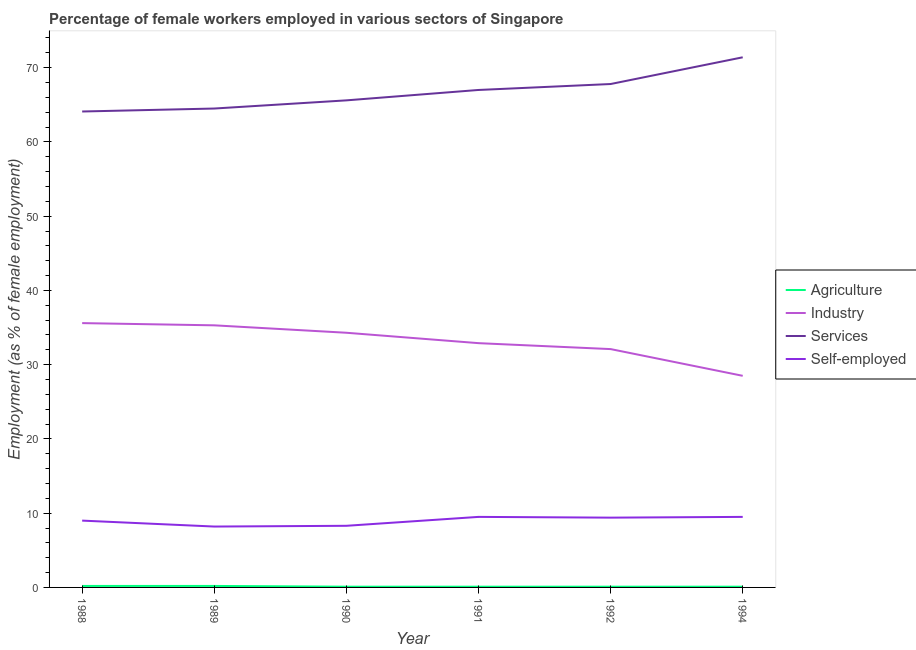How many different coloured lines are there?
Give a very brief answer. 4. Does the line corresponding to percentage of self employed female workers intersect with the line corresponding to percentage of female workers in services?
Give a very brief answer. No. What is the percentage of female workers in services in 1989?
Ensure brevity in your answer.  64.5. Across all years, what is the minimum percentage of female workers in agriculture?
Offer a terse response. 0.1. What is the total percentage of self employed female workers in the graph?
Ensure brevity in your answer.  53.9. What is the difference between the percentage of female workers in services in 1989 and that in 1992?
Keep it short and to the point. -3.3. What is the difference between the percentage of female workers in industry in 1992 and the percentage of self employed female workers in 1990?
Your answer should be compact. 23.8. What is the average percentage of female workers in industry per year?
Provide a short and direct response. 33.12. In the year 1990, what is the difference between the percentage of female workers in industry and percentage of female workers in agriculture?
Your answer should be very brief. 34.2. What is the ratio of the percentage of female workers in industry in 1991 to that in 1992?
Make the answer very short. 1.02. Is the percentage of female workers in agriculture in 1991 less than that in 1994?
Your response must be concise. No. What is the difference between the highest and the second highest percentage of female workers in industry?
Your answer should be very brief. 0.3. What is the difference between the highest and the lowest percentage of female workers in industry?
Ensure brevity in your answer.  7.1. In how many years, is the percentage of female workers in industry greater than the average percentage of female workers in industry taken over all years?
Your response must be concise. 3. Is the sum of the percentage of female workers in agriculture in 1990 and 1992 greater than the maximum percentage of self employed female workers across all years?
Offer a terse response. No. Is it the case that in every year, the sum of the percentage of female workers in industry and percentage of female workers in services is greater than the sum of percentage of female workers in agriculture and percentage of self employed female workers?
Make the answer very short. Yes. Does the percentage of female workers in agriculture monotonically increase over the years?
Ensure brevity in your answer.  No. Is the percentage of self employed female workers strictly greater than the percentage of female workers in services over the years?
Your answer should be very brief. No. Is the percentage of female workers in services strictly less than the percentage of female workers in agriculture over the years?
Provide a succinct answer. No. How many lines are there?
Give a very brief answer. 4. How many years are there in the graph?
Your answer should be compact. 6. What is the difference between two consecutive major ticks on the Y-axis?
Your answer should be compact. 10. Are the values on the major ticks of Y-axis written in scientific E-notation?
Make the answer very short. No. Does the graph contain grids?
Keep it short and to the point. No. How many legend labels are there?
Offer a terse response. 4. What is the title of the graph?
Keep it short and to the point. Percentage of female workers employed in various sectors of Singapore. What is the label or title of the Y-axis?
Offer a terse response. Employment (as % of female employment). What is the Employment (as % of female employment) in Agriculture in 1988?
Give a very brief answer. 0.2. What is the Employment (as % of female employment) of Industry in 1988?
Ensure brevity in your answer.  35.6. What is the Employment (as % of female employment) in Services in 1988?
Your response must be concise. 64.1. What is the Employment (as % of female employment) of Self-employed in 1988?
Your response must be concise. 9. What is the Employment (as % of female employment) of Agriculture in 1989?
Ensure brevity in your answer.  0.2. What is the Employment (as % of female employment) of Industry in 1989?
Your answer should be compact. 35.3. What is the Employment (as % of female employment) in Services in 1989?
Your answer should be compact. 64.5. What is the Employment (as % of female employment) of Self-employed in 1989?
Keep it short and to the point. 8.2. What is the Employment (as % of female employment) in Agriculture in 1990?
Ensure brevity in your answer.  0.1. What is the Employment (as % of female employment) of Industry in 1990?
Provide a short and direct response. 34.3. What is the Employment (as % of female employment) of Services in 1990?
Offer a terse response. 65.6. What is the Employment (as % of female employment) in Self-employed in 1990?
Your answer should be very brief. 8.3. What is the Employment (as % of female employment) in Agriculture in 1991?
Your response must be concise. 0.1. What is the Employment (as % of female employment) in Industry in 1991?
Ensure brevity in your answer.  32.9. What is the Employment (as % of female employment) of Services in 1991?
Provide a short and direct response. 67. What is the Employment (as % of female employment) of Agriculture in 1992?
Ensure brevity in your answer.  0.1. What is the Employment (as % of female employment) in Industry in 1992?
Your answer should be very brief. 32.1. What is the Employment (as % of female employment) in Services in 1992?
Provide a succinct answer. 67.8. What is the Employment (as % of female employment) in Self-employed in 1992?
Give a very brief answer. 9.4. What is the Employment (as % of female employment) in Agriculture in 1994?
Make the answer very short. 0.1. What is the Employment (as % of female employment) of Industry in 1994?
Ensure brevity in your answer.  28.5. What is the Employment (as % of female employment) in Services in 1994?
Provide a short and direct response. 71.4. What is the Employment (as % of female employment) in Self-employed in 1994?
Offer a terse response. 9.5. Across all years, what is the maximum Employment (as % of female employment) of Agriculture?
Provide a short and direct response. 0.2. Across all years, what is the maximum Employment (as % of female employment) in Industry?
Offer a very short reply. 35.6. Across all years, what is the maximum Employment (as % of female employment) of Services?
Offer a very short reply. 71.4. Across all years, what is the minimum Employment (as % of female employment) of Agriculture?
Keep it short and to the point. 0.1. Across all years, what is the minimum Employment (as % of female employment) of Industry?
Offer a terse response. 28.5. Across all years, what is the minimum Employment (as % of female employment) in Services?
Provide a short and direct response. 64.1. Across all years, what is the minimum Employment (as % of female employment) of Self-employed?
Your response must be concise. 8.2. What is the total Employment (as % of female employment) of Industry in the graph?
Provide a succinct answer. 198.7. What is the total Employment (as % of female employment) in Services in the graph?
Provide a short and direct response. 400.4. What is the total Employment (as % of female employment) of Self-employed in the graph?
Provide a succinct answer. 53.9. What is the difference between the Employment (as % of female employment) in Agriculture in 1988 and that in 1989?
Offer a terse response. 0. What is the difference between the Employment (as % of female employment) in Industry in 1988 and that in 1989?
Make the answer very short. 0.3. What is the difference between the Employment (as % of female employment) in Self-employed in 1988 and that in 1989?
Offer a terse response. 0.8. What is the difference between the Employment (as % of female employment) of Agriculture in 1988 and that in 1990?
Ensure brevity in your answer.  0.1. What is the difference between the Employment (as % of female employment) of Industry in 1988 and that in 1991?
Your answer should be very brief. 2.7. What is the difference between the Employment (as % of female employment) of Services in 1988 and that in 1991?
Give a very brief answer. -2.9. What is the difference between the Employment (as % of female employment) in Agriculture in 1988 and that in 1992?
Keep it short and to the point. 0.1. What is the difference between the Employment (as % of female employment) in Services in 1988 and that in 1992?
Provide a succinct answer. -3.7. What is the difference between the Employment (as % of female employment) in Self-employed in 1988 and that in 1992?
Your answer should be very brief. -0.4. What is the difference between the Employment (as % of female employment) of Agriculture in 1988 and that in 1994?
Your answer should be compact. 0.1. What is the difference between the Employment (as % of female employment) in Services in 1988 and that in 1994?
Your answer should be very brief. -7.3. What is the difference between the Employment (as % of female employment) in Agriculture in 1989 and that in 1990?
Give a very brief answer. 0.1. What is the difference between the Employment (as % of female employment) in Self-employed in 1989 and that in 1990?
Make the answer very short. -0.1. What is the difference between the Employment (as % of female employment) in Agriculture in 1989 and that in 1991?
Ensure brevity in your answer.  0.1. What is the difference between the Employment (as % of female employment) in Services in 1989 and that in 1991?
Offer a terse response. -2.5. What is the difference between the Employment (as % of female employment) of Agriculture in 1989 and that in 1992?
Your answer should be compact. 0.1. What is the difference between the Employment (as % of female employment) of Self-employed in 1989 and that in 1992?
Your answer should be compact. -1.2. What is the difference between the Employment (as % of female employment) of Agriculture in 1989 and that in 1994?
Ensure brevity in your answer.  0.1. What is the difference between the Employment (as % of female employment) in Industry in 1989 and that in 1994?
Provide a succinct answer. 6.8. What is the difference between the Employment (as % of female employment) in Agriculture in 1990 and that in 1991?
Provide a succinct answer. 0. What is the difference between the Employment (as % of female employment) in Agriculture in 1990 and that in 1992?
Provide a short and direct response. 0. What is the difference between the Employment (as % of female employment) of Services in 1990 and that in 1994?
Give a very brief answer. -5.8. What is the difference between the Employment (as % of female employment) in Self-employed in 1991 and that in 1992?
Make the answer very short. 0.1. What is the difference between the Employment (as % of female employment) in Services in 1991 and that in 1994?
Your response must be concise. -4.4. What is the difference between the Employment (as % of female employment) in Self-employed in 1991 and that in 1994?
Your answer should be very brief. 0. What is the difference between the Employment (as % of female employment) in Industry in 1992 and that in 1994?
Provide a succinct answer. 3.6. What is the difference between the Employment (as % of female employment) in Self-employed in 1992 and that in 1994?
Your response must be concise. -0.1. What is the difference between the Employment (as % of female employment) in Agriculture in 1988 and the Employment (as % of female employment) in Industry in 1989?
Keep it short and to the point. -35.1. What is the difference between the Employment (as % of female employment) in Agriculture in 1988 and the Employment (as % of female employment) in Services in 1989?
Provide a short and direct response. -64.3. What is the difference between the Employment (as % of female employment) in Industry in 1988 and the Employment (as % of female employment) in Services in 1989?
Keep it short and to the point. -28.9. What is the difference between the Employment (as % of female employment) of Industry in 1988 and the Employment (as % of female employment) of Self-employed in 1989?
Your answer should be very brief. 27.4. What is the difference between the Employment (as % of female employment) of Services in 1988 and the Employment (as % of female employment) of Self-employed in 1989?
Keep it short and to the point. 55.9. What is the difference between the Employment (as % of female employment) of Agriculture in 1988 and the Employment (as % of female employment) of Industry in 1990?
Ensure brevity in your answer.  -34.1. What is the difference between the Employment (as % of female employment) in Agriculture in 1988 and the Employment (as % of female employment) in Services in 1990?
Your response must be concise. -65.4. What is the difference between the Employment (as % of female employment) in Industry in 1988 and the Employment (as % of female employment) in Services in 1990?
Make the answer very short. -30. What is the difference between the Employment (as % of female employment) of Industry in 1988 and the Employment (as % of female employment) of Self-employed in 1990?
Provide a succinct answer. 27.3. What is the difference between the Employment (as % of female employment) of Services in 1988 and the Employment (as % of female employment) of Self-employed in 1990?
Make the answer very short. 55.8. What is the difference between the Employment (as % of female employment) of Agriculture in 1988 and the Employment (as % of female employment) of Industry in 1991?
Provide a short and direct response. -32.7. What is the difference between the Employment (as % of female employment) in Agriculture in 1988 and the Employment (as % of female employment) in Services in 1991?
Your answer should be very brief. -66.8. What is the difference between the Employment (as % of female employment) of Industry in 1988 and the Employment (as % of female employment) of Services in 1991?
Make the answer very short. -31.4. What is the difference between the Employment (as % of female employment) in Industry in 1988 and the Employment (as % of female employment) in Self-employed in 1991?
Your response must be concise. 26.1. What is the difference between the Employment (as % of female employment) in Services in 1988 and the Employment (as % of female employment) in Self-employed in 1991?
Your answer should be very brief. 54.6. What is the difference between the Employment (as % of female employment) in Agriculture in 1988 and the Employment (as % of female employment) in Industry in 1992?
Your answer should be very brief. -31.9. What is the difference between the Employment (as % of female employment) in Agriculture in 1988 and the Employment (as % of female employment) in Services in 1992?
Ensure brevity in your answer.  -67.6. What is the difference between the Employment (as % of female employment) of Industry in 1988 and the Employment (as % of female employment) of Services in 1992?
Make the answer very short. -32.2. What is the difference between the Employment (as % of female employment) of Industry in 1988 and the Employment (as % of female employment) of Self-employed in 1992?
Your answer should be very brief. 26.2. What is the difference between the Employment (as % of female employment) of Services in 1988 and the Employment (as % of female employment) of Self-employed in 1992?
Keep it short and to the point. 54.7. What is the difference between the Employment (as % of female employment) of Agriculture in 1988 and the Employment (as % of female employment) of Industry in 1994?
Make the answer very short. -28.3. What is the difference between the Employment (as % of female employment) in Agriculture in 1988 and the Employment (as % of female employment) in Services in 1994?
Your answer should be very brief. -71.2. What is the difference between the Employment (as % of female employment) in Industry in 1988 and the Employment (as % of female employment) in Services in 1994?
Your response must be concise. -35.8. What is the difference between the Employment (as % of female employment) in Industry in 1988 and the Employment (as % of female employment) in Self-employed in 1994?
Give a very brief answer. 26.1. What is the difference between the Employment (as % of female employment) of Services in 1988 and the Employment (as % of female employment) of Self-employed in 1994?
Make the answer very short. 54.6. What is the difference between the Employment (as % of female employment) in Agriculture in 1989 and the Employment (as % of female employment) in Industry in 1990?
Keep it short and to the point. -34.1. What is the difference between the Employment (as % of female employment) in Agriculture in 1989 and the Employment (as % of female employment) in Services in 1990?
Give a very brief answer. -65.4. What is the difference between the Employment (as % of female employment) of Industry in 1989 and the Employment (as % of female employment) of Services in 1990?
Keep it short and to the point. -30.3. What is the difference between the Employment (as % of female employment) in Industry in 1989 and the Employment (as % of female employment) in Self-employed in 1990?
Your answer should be compact. 27. What is the difference between the Employment (as % of female employment) of Services in 1989 and the Employment (as % of female employment) of Self-employed in 1990?
Offer a very short reply. 56.2. What is the difference between the Employment (as % of female employment) in Agriculture in 1989 and the Employment (as % of female employment) in Industry in 1991?
Your answer should be very brief. -32.7. What is the difference between the Employment (as % of female employment) in Agriculture in 1989 and the Employment (as % of female employment) in Services in 1991?
Offer a very short reply. -66.8. What is the difference between the Employment (as % of female employment) in Industry in 1989 and the Employment (as % of female employment) in Services in 1991?
Keep it short and to the point. -31.7. What is the difference between the Employment (as % of female employment) of Industry in 1989 and the Employment (as % of female employment) of Self-employed in 1991?
Offer a terse response. 25.8. What is the difference between the Employment (as % of female employment) in Services in 1989 and the Employment (as % of female employment) in Self-employed in 1991?
Provide a short and direct response. 55. What is the difference between the Employment (as % of female employment) of Agriculture in 1989 and the Employment (as % of female employment) of Industry in 1992?
Your answer should be compact. -31.9. What is the difference between the Employment (as % of female employment) in Agriculture in 1989 and the Employment (as % of female employment) in Services in 1992?
Give a very brief answer. -67.6. What is the difference between the Employment (as % of female employment) of Industry in 1989 and the Employment (as % of female employment) of Services in 1992?
Offer a terse response. -32.5. What is the difference between the Employment (as % of female employment) in Industry in 1989 and the Employment (as % of female employment) in Self-employed in 1992?
Ensure brevity in your answer.  25.9. What is the difference between the Employment (as % of female employment) in Services in 1989 and the Employment (as % of female employment) in Self-employed in 1992?
Your answer should be very brief. 55.1. What is the difference between the Employment (as % of female employment) of Agriculture in 1989 and the Employment (as % of female employment) of Industry in 1994?
Your answer should be very brief. -28.3. What is the difference between the Employment (as % of female employment) of Agriculture in 1989 and the Employment (as % of female employment) of Services in 1994?
Offer a very short reply. -71.2. What is the difference between the Employment (as % of female employment) of Industry in 1989 and the Employment (as % of female employment) of Services in 1994?
Provide a short and direct response. -36.1. What is the difference between the Employment (as % of female employment) in Industry in 1989 and the Employment (as % of female employment) in Self-employed in 1994?
Make the answer very short. 25.8. What is the difference between the Employment (as % of female employment) in Services in 1989 and the Employment (as % of female employment) in Self-employed in 1994?
Your response must be concise. 55. What is the difference between the Employment (as % of female employment) in Agriculture in 1990 and the Employment (as % of female employment) in Industry in 1991?
Provide a succinct answer. -32.8. What is the difference between the Employment (as % of female employment) in Agriculture in 1990 and the Employment (as % of female employment) in Services in 1991?
Make the answer very short. -66.9. What is the difference between the Employment (as % of female employment) in Industry in 1990 and the Employment (as % of female employment) in Services in 1991?
Ensure brevity in your answer.  -32.7. What is the difference between the Employment (as % of female employment) of Industry in 1990 and the Employment (as % of female employment) of Self-employed in 1991?
Ensure brevity in your answer.  24.8. What is the difference between the Employment (as % of female employment) of Services in 1990 and the Employment (as % of female employment) of Self-employed in 1991?
Provide a short and direct response. 56.1. What is the difference between the Employment (as % of female employment) in Agriculture in 1990 and the Employment (as % of female employment) in Industry in 1992?
Give a very brief answer. -32. What is the difference between the Employment (as % of female employment) of Agriculture in 1990 and the Employment (as % of female employment) of Services in 1992?
Provide a succinct answer. -67.7. What is the difference between the Employment (as % of female employment) in Industry in 1990 and the Employment (as % of female employment) in Services in 1992?
Keep it short and to the point. -33.5. What is the difference between the Employment (as % of female employment) in Industry in 1990 and the Employment (as % of female employment) in Self-employed in 1992?
Make the answer very short. 24.9. What is the difference between the Employment (as % of female employment) in Services in 1990 and the Employment (as % of female employment) in Self-employed in 1992?
Offer a terse response. 56.2. What is the difference between the Employment (as % of female employment) in Agriculture in 1990 and the Employment (as % of female employment) in Industry in 1994?
Your answer should be very brief. -28.4. What is the difference between the Employment (as % of female employment) of Agriculture in 1990 and the Employment (as % of female employment) of Services in 1994?
Your answer should be compact. -71.3. What is the difference between the Employment (as % of female employment) in Agriculture in 1990 and the Employment (as % of female employment) in Self-employed in 1994?
Provide a short and direct response. -9.4. What is the difference between the Employment (as % of female employment) in Industry in 1990 and the Employment (as % of female employment) in Services in 1994?
Provide a short and direct response. -37.1. What is the difference between the Employment (as % of female employment) of Industry in 1990 and the Employment (as % of female employment) of Self-employed in 1994?
Your answer should be compact. 24.8. What is the difference between the Employment (as % of female employment) of Services in 1990 and the Employment (as % of female employment) of Self-employed in 1994?
Provide a succinct answer. 56.1. What is the difference between the Employment (as % of female employment) of Agriculture in 1991 and the Employment (as % of female employment) of Industry in 1992?
Provide a short and direct response. -32. What is the difference between the Employment (as % of female employment) of Agriculture in 1991 and the Employment (as % of female employment) of Services in 1992?
Your answer should be very brief. -67.7. What is the difference between the Employment (as % of female employment) in Agriculture in 1991 and the Employment (as % of female employment) in Self-employed in 1992?
Provide a succinct answer. -9.3. What is the difference between the Employment (as % of female employment) in Industry in 1991 and the Employment (as % of female employment) in Services in 1992?
Your answer should be compact. -34.9. What is the difference between the Employment (as % of female employment) of Services in 1991 and the Employment (as % of female employment) of Self-employed in 1992?
Offer a terse response. 57.6. What is the difference between the Employment (as % of female employment) in Agriculture in 1991 and the Employment (as % of female employment) in Industry in 1994?
Offer a terse response. -28.4. What is the difference between the Employment (as % of female employment) in Agriculture in 1991 and the Employment (as % of female employment) in Services in 1994?
Your answer should be very brief. -71.3. What is the difference between the Employment (as % of female employment) of Industry in 1991 and the Employment (as % of female employment) of Services in 1994?
Provide a short and direct response. -38.5. What is the difference between the Employment (as % of female employment) in Industry in 1991 and the Employment (as % of female employment) in Self-employed in 1994?
Keep it short and to the point. 23.4. What is the difference between the Employment (as % of female employment) of Services in 1991 and the Employment (as % of female employment) of Self-employed in 1994?
Keep it short and to the point. 57.5. What is the difference between the Employment (as % of female employment) of Agriculture in 1992 and the Employment (as % of female employment) of Industry in 1994?
Your answer should be very brief. -28.4. What is the difference between the Employment (as % of female employment) of Agriculture in 1992 and the Employment (as % of female employment) of Services in 1994?
Make the answer very short. -71.3. What is the difference between the Employment (as % of female employment) in Agriculture in 1992 and the Employment (as % of female employment) in Self-employed in 1994?
Make the answer very short. -9.4. What is the difference between the Employment (as % of female employment) of Industry in 1992 and the Employment (as % of female employment) of Services in 1994?
Your answer should be compact. -39.3. What is the difference between the Employment (as % of female employment) in Industry in 1992 and the Employment (as % of female employment) in Self-employed in 1994?
Keep it short and to the point. 22.6. What is the difference between the Employment (as % of female employment) in Services in 1992 and the Employment (as % of female employment) in Self-employed in 1994?
Your answer should be very brief. 58.3. What is the average Employment (as % of female employment) of Agriculture per year?
Offer a very short reply. 0.13. What is the average Employment (as % of female employment) of Industry per year?
Offer a terse response. 33.12. What is the average Employment (as % of female employment) in Services per year?
Your answer should be very brief. 66.73. What is the average Employment (as % of female employment) of Self-employed per year?
Make the answer very short. 8.98. In the year 1988, what is the difference between the Employment (as % of female employment) in Agriculture and Employment (as % of female employment) in Industry?
Offer a very short reply. -35.4. In the year 1988, what is the difference between the Employment (as % of female employment) of Agriculture and Employment (as % of female employment) of Services?
Give a very brief answer. -63.9. In the year 1988, what is the difference between the Employment (as % of female employment) of Agriculture and Employment (as % of female employment) of Self-employed?
Provide a succinct answer. -8.8. In the year 1988, what is the difference between the Employment (as % of female employment) of Industry and Employment (as % of female employment) of Services?
Keep it short and to the point. -28.5. In the year 1988, what is the difference between the Employment (as % of female employment) of Industry and Employment (as % of female employment) of Self-employed?
Your response must be concise. 26.6. In the year 1988, what is the difference between the Employment (as % of female employment) of Services and Employment (as % of female employment) of Self-employed?
Provide a succinct answer. 55.1. In the year 1989, what is the difference between the Employment (as % of female employment) of Agriculture and Employment (as % of female employment) of Industry?
Your answer should be compact. -35.1. In the year 1989, what is the difference between the Employment (as % of female employment) in Agriculture and Employment (as % of female employment) in Services?
Give a very brief answer. -64.3. In the year 1989, what is the difference between the Employment (as % of female employment) of Industry and Employment (as % of female employment) of Services?
Your answer should be very brief. -29.2. In the year 1989, what is the difference between the Employment (as % of female employment) of Industry and Employment (as % of female employment) of Self-employed?
Give a very brief answer. 27.1. In the year 1989, what is the difference between the Employment (as % of female employment) in Services and Employment (as % of female employment) in Self-employed?
Keep it short and to the point. 56.3. In the year 1990, what is the difference between the Employment (as % of female employment) of Agriculture and Employment (as % of female employment) of Industry?
Provide a short and direct response. -34.2. In the year 1990, what is the difference between the Employment (as % of female employment) in Agriculture and Employment (as % of female employment) in Services?
Offer a very short reply. -65.5. In the year 1990, what is the difference between the Employment (as % of female employment) of Agriculture and Employment (as % of female employment) of Self-employed?
Give a very brief answer. -8.2. In the year 1990, what is the difference between the Employment (as % of female employment) of Industry and Employment (as % of female employment) of Services?
Make the answer very short. -31.3. In the year 1990, what is the difference between the Employment (as % of female employment) in Services and Employment (as % of female employment) in Self-employed?
Ensure brevity in your answer.  57.3. In the year 1991, what is the difference between the Employment (as % of female employment) in Agriculture and Employment (as % of female employment) in Industry?
Provide a short and direct response. -32.8. In the year 1991, what is the difference between the Employment (as % of female employment) in Agriculture and Employment (as % of female employment) in Services?
Offer a very short reply. -66.9. In the year 1991, what is the difference between the Employment (as % of female employment) in Agriculture and Employment (as % of female employment) in Self-employed?
Make the answer very short. -9.4. In the year 1991, what is the difference between the Employment (as % of female employment) of Industry and Employment (as % of female employment) of Services?
Your answer should be very brief. -34.1. In the year 1991, what is the difference between the Employment (as % of female employment) of Industry and Employment (as % of female employment) of Self-employed?
Your answer should be compact. 23.4. In the year 1991, what is the difference between the Employment (as % of female employment) of Services and Employment (as % of female employment) of Self-employed?
Provide a short and direct response. 57.5. In the year 1992, what is the difference between the Employment (as % of female employment) of Agriculture and Employment (as % of female employment) of Industry?
Your answer should be very brief. -32. In the year 1992, what is the difference between the Employment (as % of female employment) in Agriculture and Employment (as % of female employment) in Services?
Provide a short and direct response. -67.7. In the year 1992, what is the difference between the Employment (as % of female employment) of Agriculture and Employment (as % of female employment) of Self-employed?
Your response must be concise. -9.3. In the year 1992, what is the difference between the Employment (as % of female employment) in Industry and Employment (as % of female employment) in Services?
Give a very brief answer. -35.7. In the year 1992, what is the difference between the Employment (as % of female employment) of Industry and Employment (as % of female employment) of Self-employed?
Provide a succinct answer. 22.7. In the year 1992, what is the difference between the Employment (as % of female employment) in Services and Employment (as % of female employment) in Self-employed?
Provide a short and direct response. 58.4. In the year 1994, what is the difference between the Employment (as % of female employment) of Agriculture and Employment (as % of female employment) of Industry?
Your answer should be compact. -28.4. In the year 1994, what is the difference between the Employment (as % of female employment) in Agriculture and Employment (as % of female employment) in Services?
Give a very brief answer. -71.3. In the year 1994, what is the difference between the Employment (as % of female employment) of Agriculture and Employment (as % of female employment) of Self-employed?
Keep it short and to the point. -9.4. In the year 1994, what is the difference between the Employment (as % of female employment) of Industry and Employment (as % of female employment) of Services?
Make the answer very short. -42.9. In the year 1994, what is the difference between the Employment (as % of female employment) in Services and Employment (as % of female employment) in Self-employed?
Your answer should be compact. 61.9. What is the ratio of the Employment (as % of female employment) of Agriculture in 1988 to that in 1989?
Your response must be concise. 1. What is the ratio of the Employment (as % of female employment) of Industry in 1988 to that in 1989?
Your response must be concise. 1.01. What is the ratio of the Employment (as % of female employment) of Services in 1988 to that in 1989?
Provide a short and direct response. 0.99. What is the ratio of the Employment (as % of female employment) of Self-employed in 1988 to that in 1989?
Make the answer very short. 1.1. What is the ratio of the Employment (as % of female employment) of Agriculture in 1988 to that in 1990?
Give a very brief answer. 2. What is the ratio of the Employment (as % of female employment) of Industry in 1988 to that in 1990?
Provide a succinct answer. 1.04. What is the ratio of the Employment (as % of female employment) of Services in 1988 to that in 1990?
Make the answer very short. 0.98. What is the ratio of the Employment (as % of female employment) in Self-employed in 1988 to that in 1990?
Your response must be concise. 1.08. What is the ratio of the Employment (as % of female employment) of Industry in 1988 to that in 1991?
Provide a short and direct response. 1.08. What is the ratio of the Employment (as % of female employment) in Services in 1988 to that in 1991?
Your response must be concise. 0.96. What is the ratio of the Employment (as % of female employment) of Industry in 1988 to that in 1992?
Offer a very short reply. 1.11. What is the ratio of the Employment (as % of female employment) in Services in 1988 to that in 1992?
Provide a succinct answer. 0.95. What is the ratio of the Employment (as % of female employment) of Self-employed in 1988 to that in 1992?
Your answer should be compact. 0.96. What is the ratio of the Employment (as % of female employment) of Industry in 1988 to that in 1994?
Give a very brief answer. 1.25. What is the ratio of the Employment (as % of female employment) of Services in 1988 to that in 1994?
Provide a short and direct response. 0.9. What is the ratio of the Employment (as % of female employment) in Self-employed in 1988 to that in 1994?
Offer a very short reply. 0.95. What is the ratio of the Employment (as % of female employment) in Industry in 1989 to that in 1990?
Provide a short and direct response. 1.03. What is the ratio of the Employment (as % of female employment) in Services in 1989 to that in 1990?
Your response must be concise. 0.98. What is the ratio of the Employment (as % of female employment) in Agriculture in 1989 to that in 1991?
Make the answer very short. 2. What is the ratio of the Employment (as % of female employment) of Industry in 1989 to that in 1991?
Ensure brevity in your answer.  1.07. What is the ratio of the Employment (as % of female employment) in Services in 1989 to that in 1991?
Ensure brevity in your answer.  0.96. What is the ratio of the Employment (as % of female employment) of Self-employed in 1989 to that in 1991?
Offer a terse response. 0.86. What is the ratio of the Employment (as % of female employment) of Industry in 1989 to that in 1992?
Your answer should be very brief. 1.1. What is the ratio of the Employment (as % of female employment) in Services in 1989 to that in 1992?
Offer a terse response. 0.95. What is the ratio of the Employment (as % of female employment) of Self-employed in 1989 to that in 1992?
Ensure brevity in your answer.  0.87. What is the ratio of the Employment (as % of female employment) in Agriculture in 1989 to that in 1994?
Provide a succinct answer. 2. What is the ratio of the Employment (as % of female employment) in Industry in 1989 to that in 1994?
Keep it short and to the point. 1.24. What is the ratio of the Employment (as % of female employment) of Services in 1989 to that in 1994?
Ensure brevity in your answer.  0.9. What is the ratio of the Employment (as % of female employment) in Self-employed in 1989 to that in 1994?
Your answer should be very brief. 0.86. What is the ratio of the Employment (as % of female employment) of Agriculture in 1990 to that in 1991?
Your answer should be compact. 1. What is the ratio of the Employment (as % of female employment) of Industry in 1990 to that in 1991?
Keep it short and to the point. 1.04. What is the ratio of the Employment (as % of female employment) of Services in 1990 to that in 1991?
Make the answer very short. 0.98. What is the ratio of the Employment (as % of female employment) of Self-employed in 1990 to that in 1991?
Your response must be concise. 0.87. What is the ratio of the Employment (as % of female employment) in Industry in 1990 to that in 1992?
Make the answer very short. 1.07. What is the ratio of the Employment (as % of female employment) of Services in 1990 to that in 1992?
Ensure brevity in your answer.  0.97. What is the ratio of the Employment (as % of female employment) in Self-employed in 1990 to that in 1992?
Provide a succinct answer. 0.88. What is the ratio of the Employment (as % of female employment) of Agriculture in 1990 to that in 1994?
Your answer should be very brief. 1. What is the ratio of the Employment (as % of female employment) of Industry in 1990 to that in 1994?
Provide a succinct answer. 1.2. What is the ratio of the Employment (as % of female employment) of Services in 1990 to that in 1994?
Offer a terse response. 0.92. What is the ratio of the Employment (as % of female employment) of Self-employed in 1990 to that in 1994?
Offer a very short reply. 0.87. What is the ratio of the Employment (as % of female employment) of Industry in 1991 to that in 1992?
Offer a very short reply. 1.02. What is the ratio of the Employment (as % of female employment) of Self-employed in 1991 to that in 1992?
Offer a terse response. 1.01. What is the ratio of the Employment (as % of female employment) in Agriculture in 1991 to that in 1994?
Make the answer very short. 1. What is the ratio of the Employment (as % of female employment) in Industry in 1991 to that in 1994?
Provide a succinct answer. 1.15. What is the ratio of the Employment (as % of female employment) of Services in 1991 to that in 1994?
Offer a very short reply. 0.94. What is the ratio of the Employment (as % of female employment) of Self-employed in 1991 to that in 1994?
Ensure brevity in your answer.  1. What is the ratio of the Employment (as % of female employment) in Agriculture in 1992 to that in 1994?
Make the answer very short. 1. What is the ratio of the Employment (as % of female employment) of Industry in 1992 to that in 1994?
Provide a succinct answer. 1.13. What is the ratio of the Employment (as % of female employment) of Services in 1992 to that in 1994?
Offer a very short reply. 0.95. What is the difference between the highest and the lowest Employment (as % of female employment) of Industry?
Offer a very short reply. 7.1. 